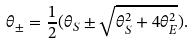<formula> <loc_0><loc_0><loc_500><loc_500>\theta _ { \pm } = \frac { 1 } { 2 } ( \theta _ { S } \pm \sqrt { \theta _ { S } ^ { 2 } + 4 \theta _ { E } ^ { 2 } } ) .</formula> 